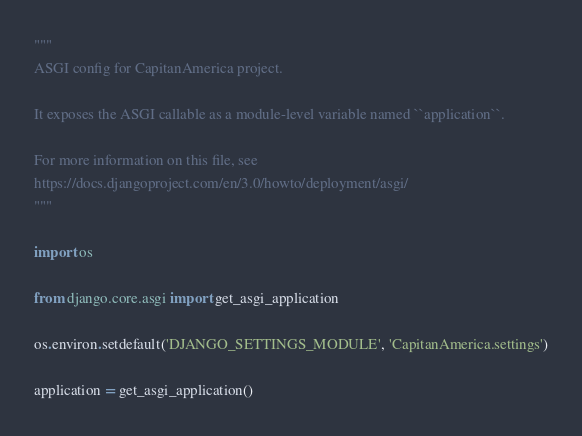Convert code to text. <code><loc_0><loc_0><loc_500><loc_500><_Python_>"""
ASGI config for CapitanAmerica project.

It exposes the ASGI callable as a module-level variable named ``application``.

For more information on this file, see
https://docs.djangoproject.com/en/3.0/howto/deployment/asgi/
"""

import os

from django.core.asgi import get_asgi_application

os.environ.setdefault('DJANGO_SETTINGS_MODULE', 'CapitanAmerica.settings')

application = get_asgi_application()
</code> 